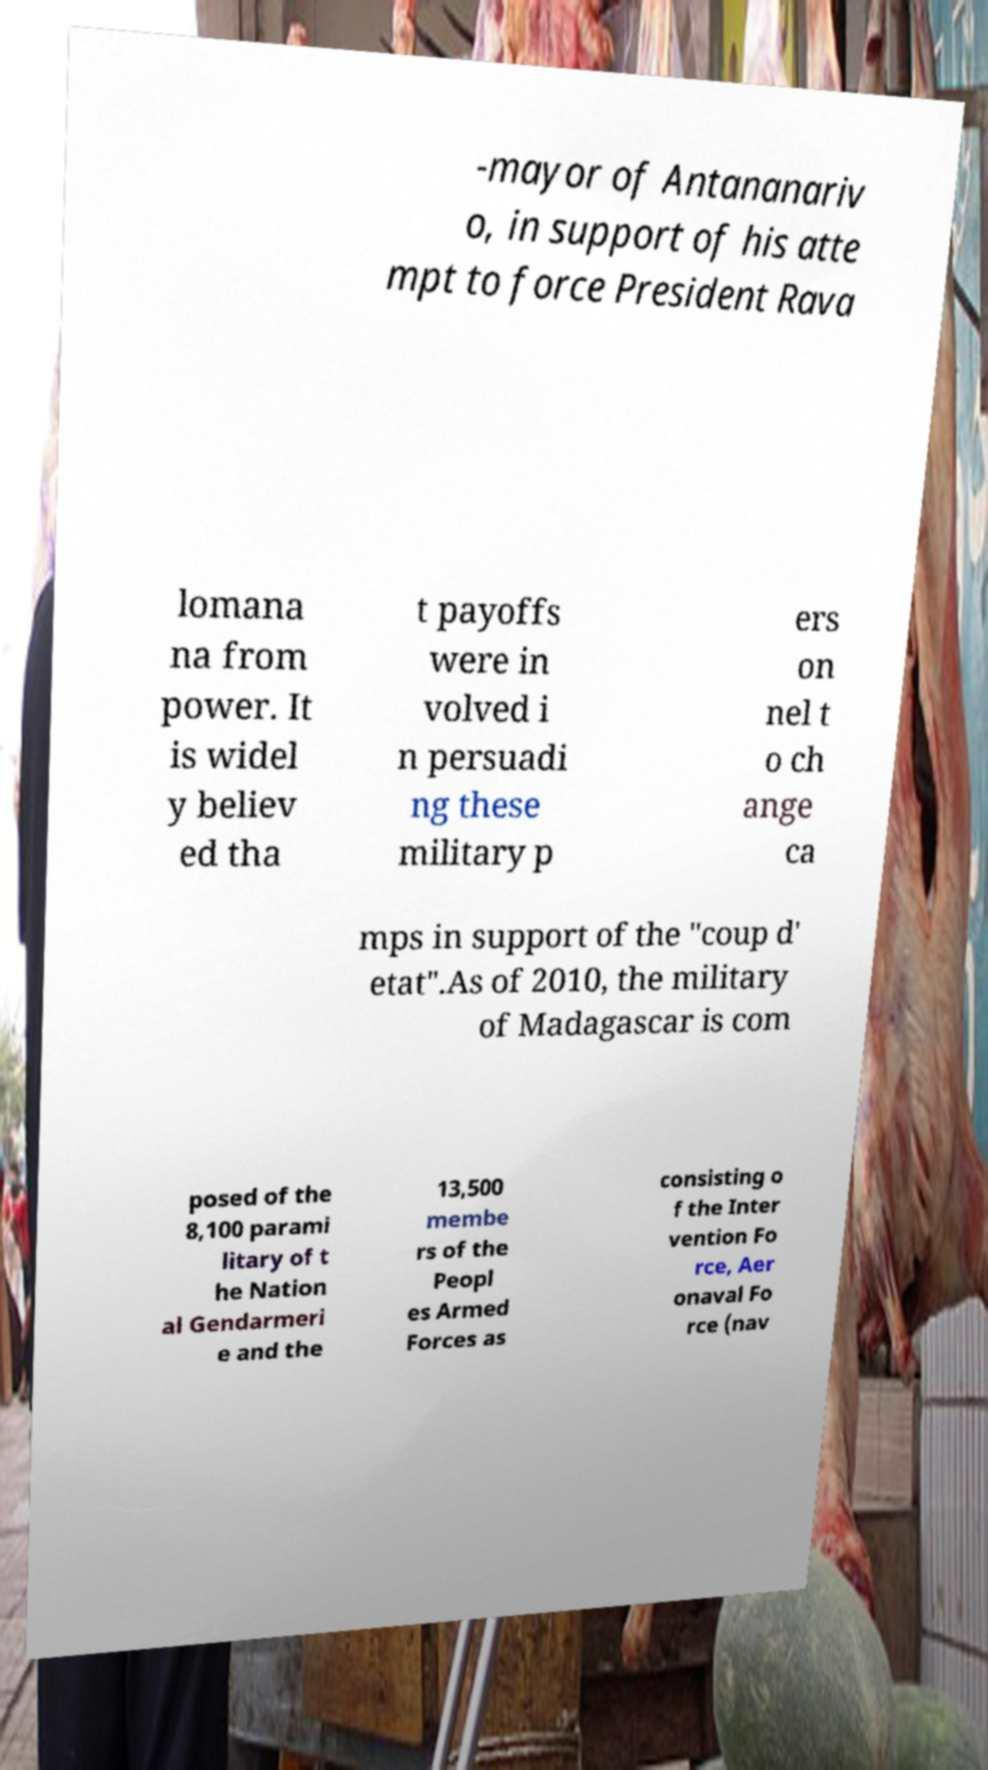I need the written content from this picture converted into text. Can you do that? -mayor of Antananariv o, in support of his atte mpt to force President Rava lomana na from power. It is widel y believ ed tha t payoffs were in volved i n persuadi ng these military p ers on nel t o ch ange ca mps in support of the "coup d' etat".As of 2010, the military of Madagascar is com posed of the 8,100 parami litary of t he Nation al Gendarmeri e and the 13,500 membe rs of the Peopl es Armed Forces as consisting o f the Inter vention Fo rce, Aer onaval Fo rce (nav 